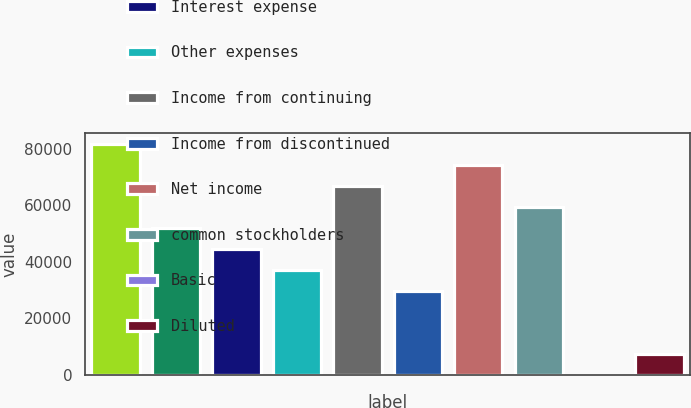Convert chart to OTSL. <chart><loc_0><loc_0><loc_500><loc_500><bar_chart><fcel>Total revenue<fcel>Depreciation and amortization<fcel>Interest expense<fcel>Other expenses<fcel>Income from continuing<fcel>Income from discontinued<fcel>Net income<fcel>common stockholders<fcel>Basic<fcel>Diluted<nl><fcel>81487.9<fcel>51856.1<fcel>44448.1<fcel>37040.1<fcel>66672<fcel>29632.2<fcel>74080<fcel>59264<fcel>0.28<fcel>7408.25<nl></chart> 